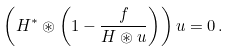<formula> <loc_0><loc_0><loc_500><loc_500>\left ( H ^ { * } \circledast \left ( 1 - \frac { f } { H \circledast u } \right ) \right ) u = 0 \, .</formula> 